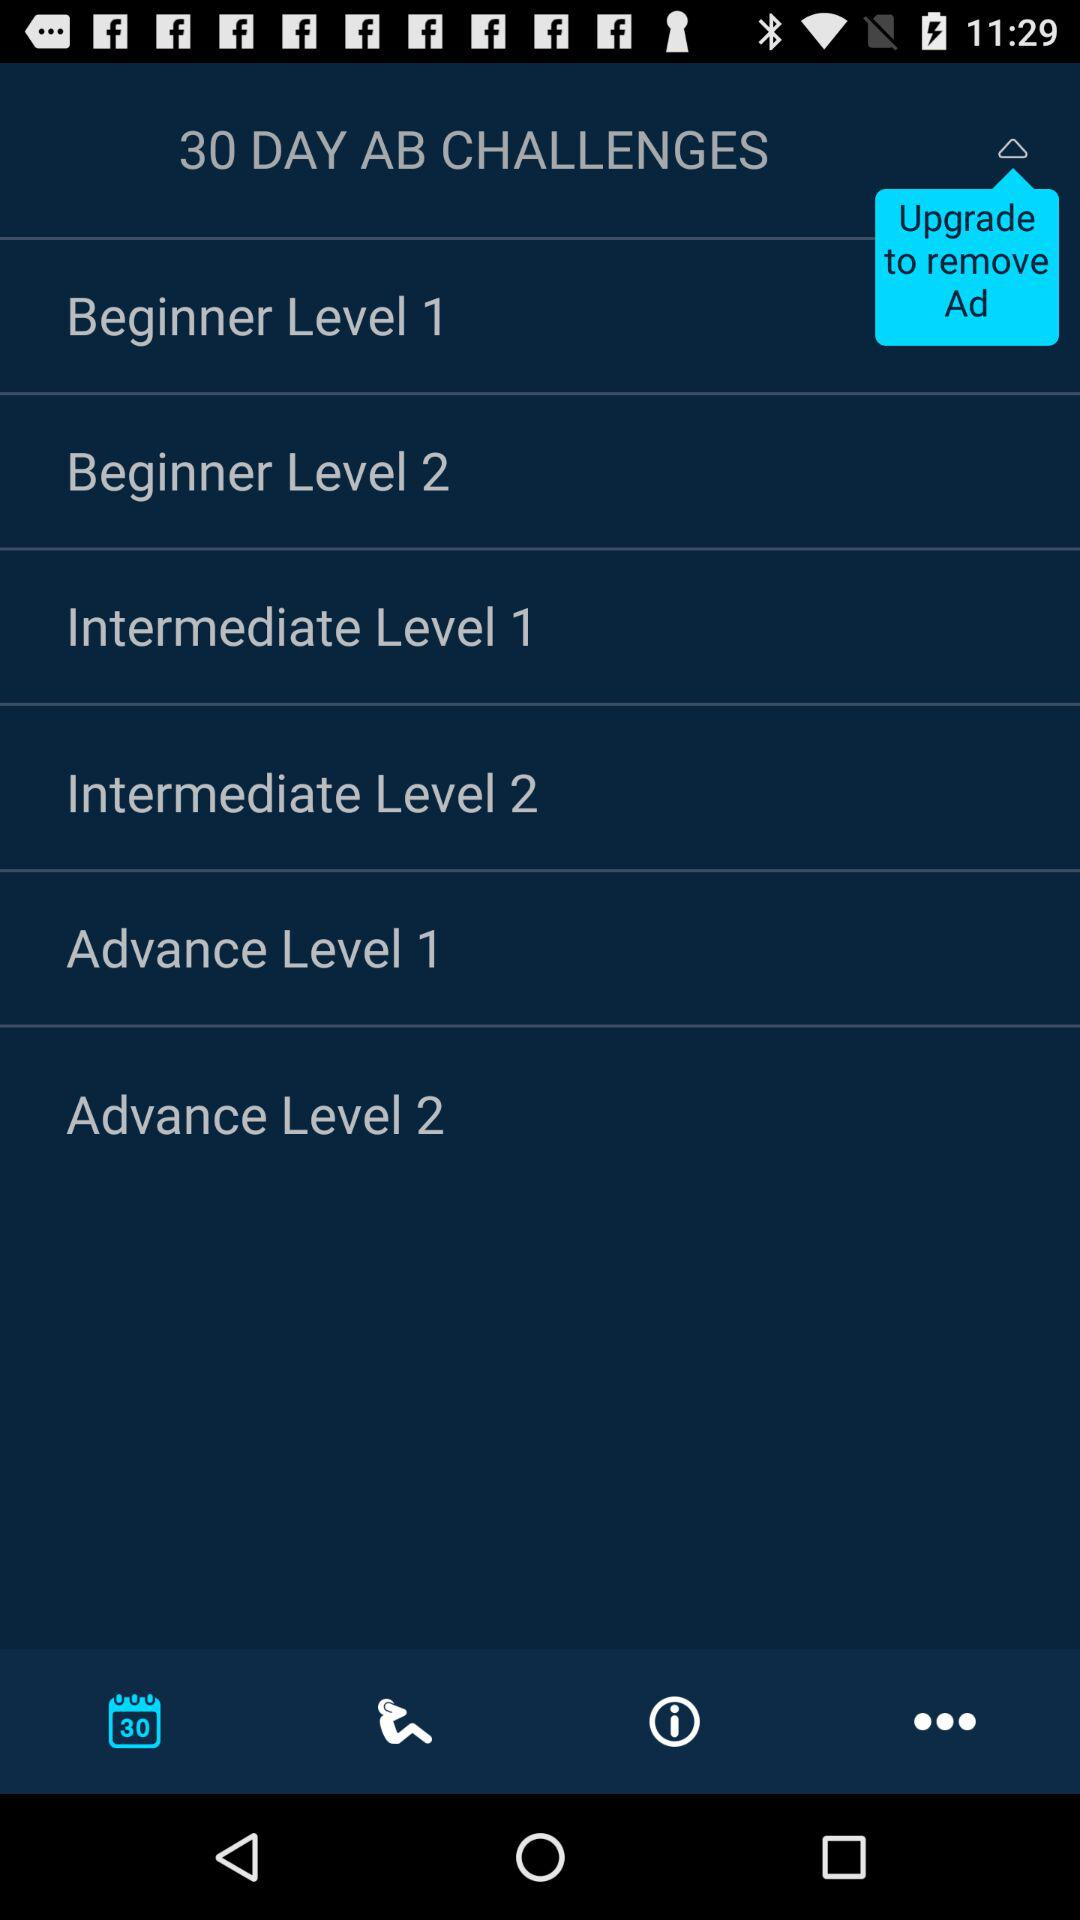How many days are the AB challenges for? The AB challenges are for 30 days. 